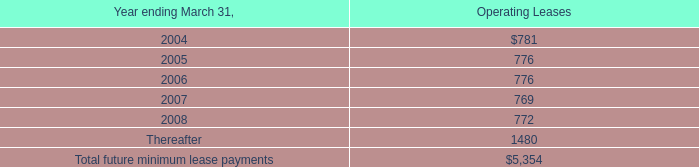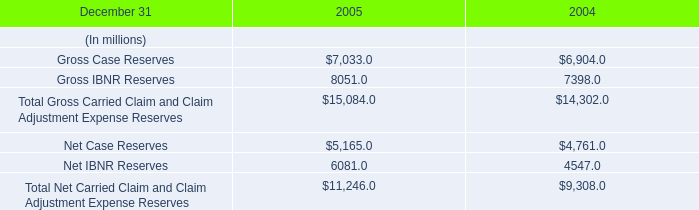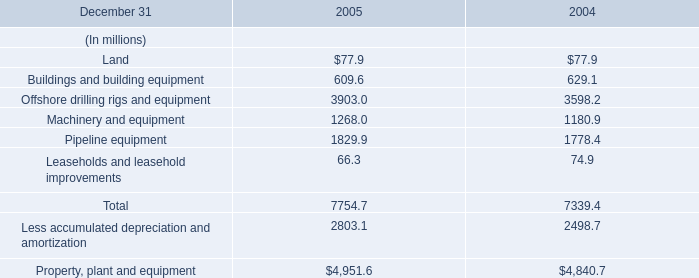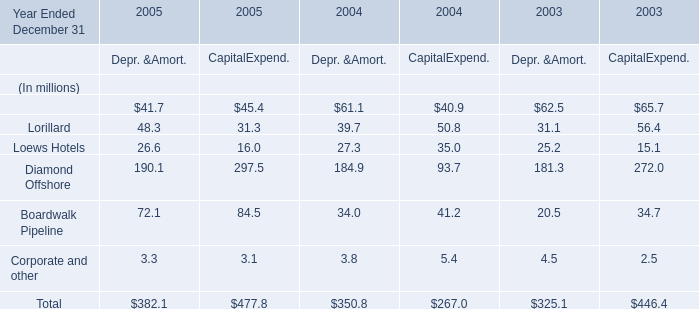What is the total amount of Gross Case Reserves of 2005, and Pipeline equipment of 2005 ? 
Computations: (7033.0 + 1829.9)
Answer: 8862.9. 